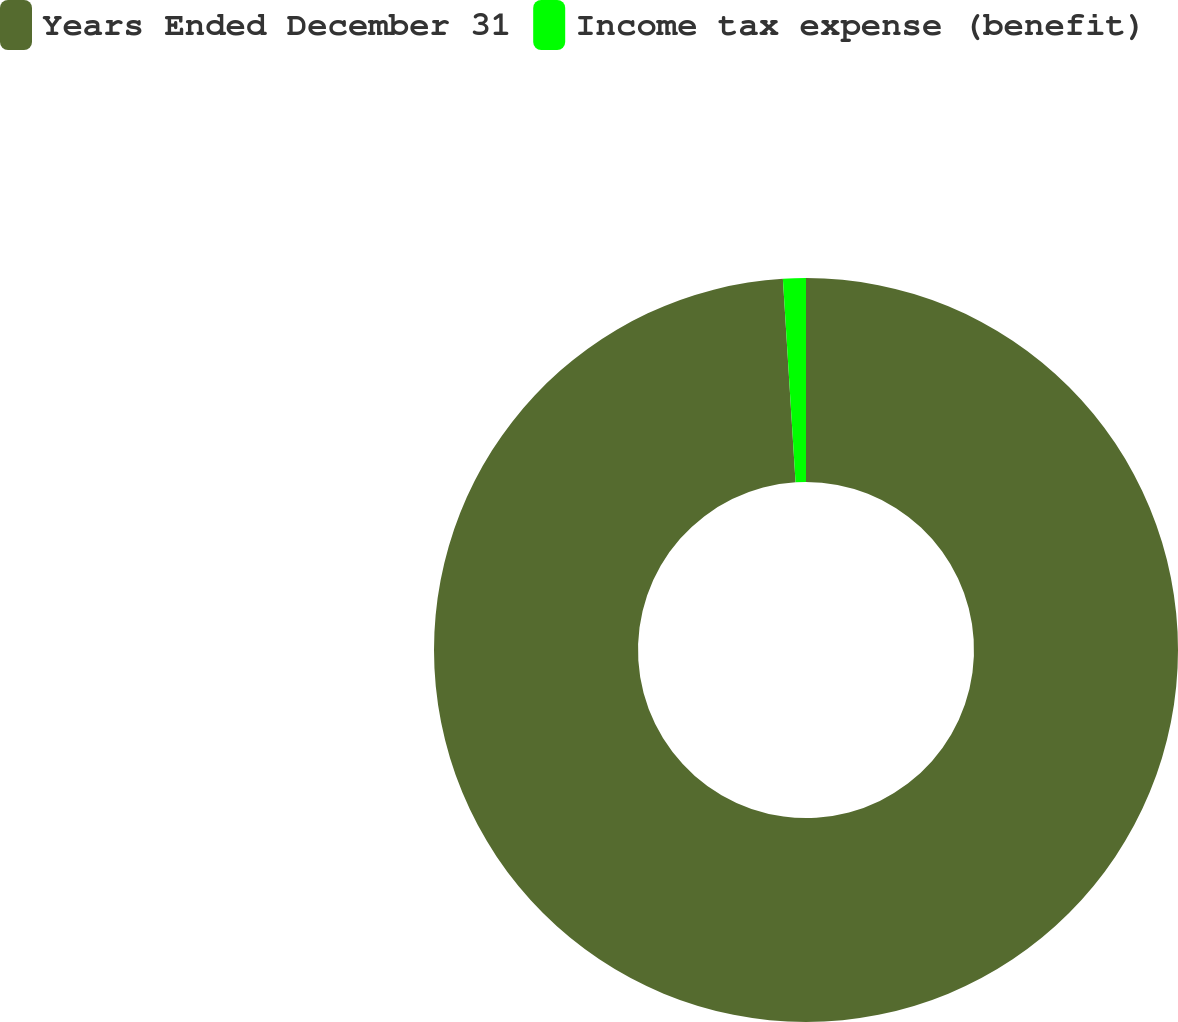Convert chart. <chart><loc_0><loc_0><loc_500><loc_500><pie_chart><fcel>Years Ended December 31<fcel>Income tax expense (benefit)<nl><fcel>99.01%<fcel>0.99%<nl></chart> 